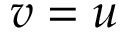<formula> <loc_0><loc_0><loc_500><loc_500>v = u</formula> 